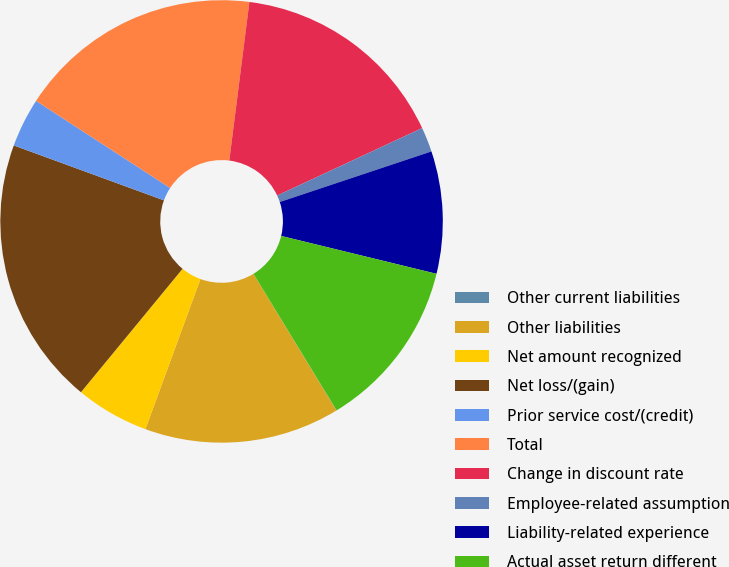<chart> <loc_0><loc_0><loc_500><loc_500><pie_chart><fcel>Other current liabilities<fcel>Other liabilities<fcel>Net amount recognized<fcel>Net loss/(gain)<fcel>Prior service cost/(credit)<fcel>Total<fcel>Change in discount rate<fcel>Employee-related assumption<fcel>Liability-related experience<fcel>Actual asset return different<nl><fcel>0.02%<fcel>14.28%<fcel>5.37%<fcel>19.62%<fcel>3.59%<fcel>17.84%<fcel>16.06%<fcel>1.81%<fcel>8.93%<fcel>12.49%<nl></chart> 